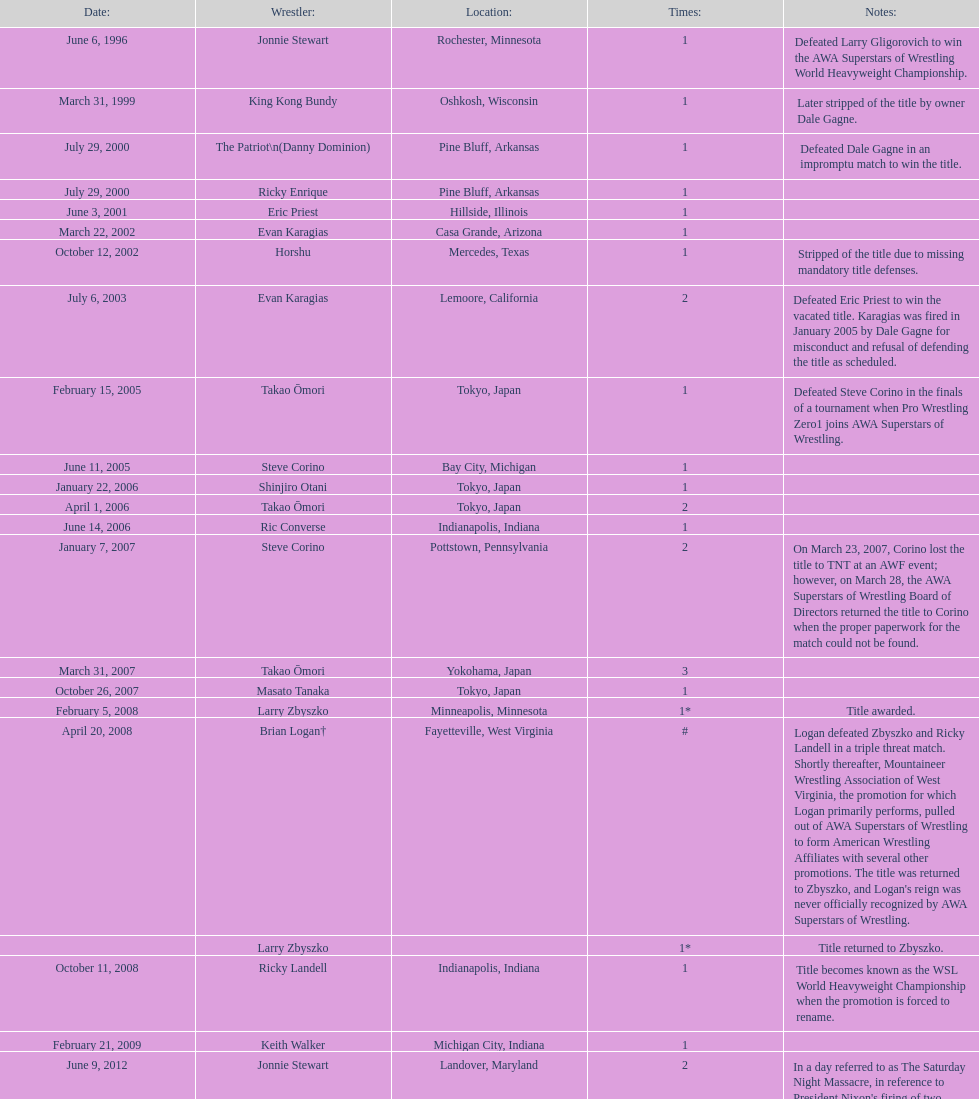Who is listed before keith walker? Ricky Landell. 